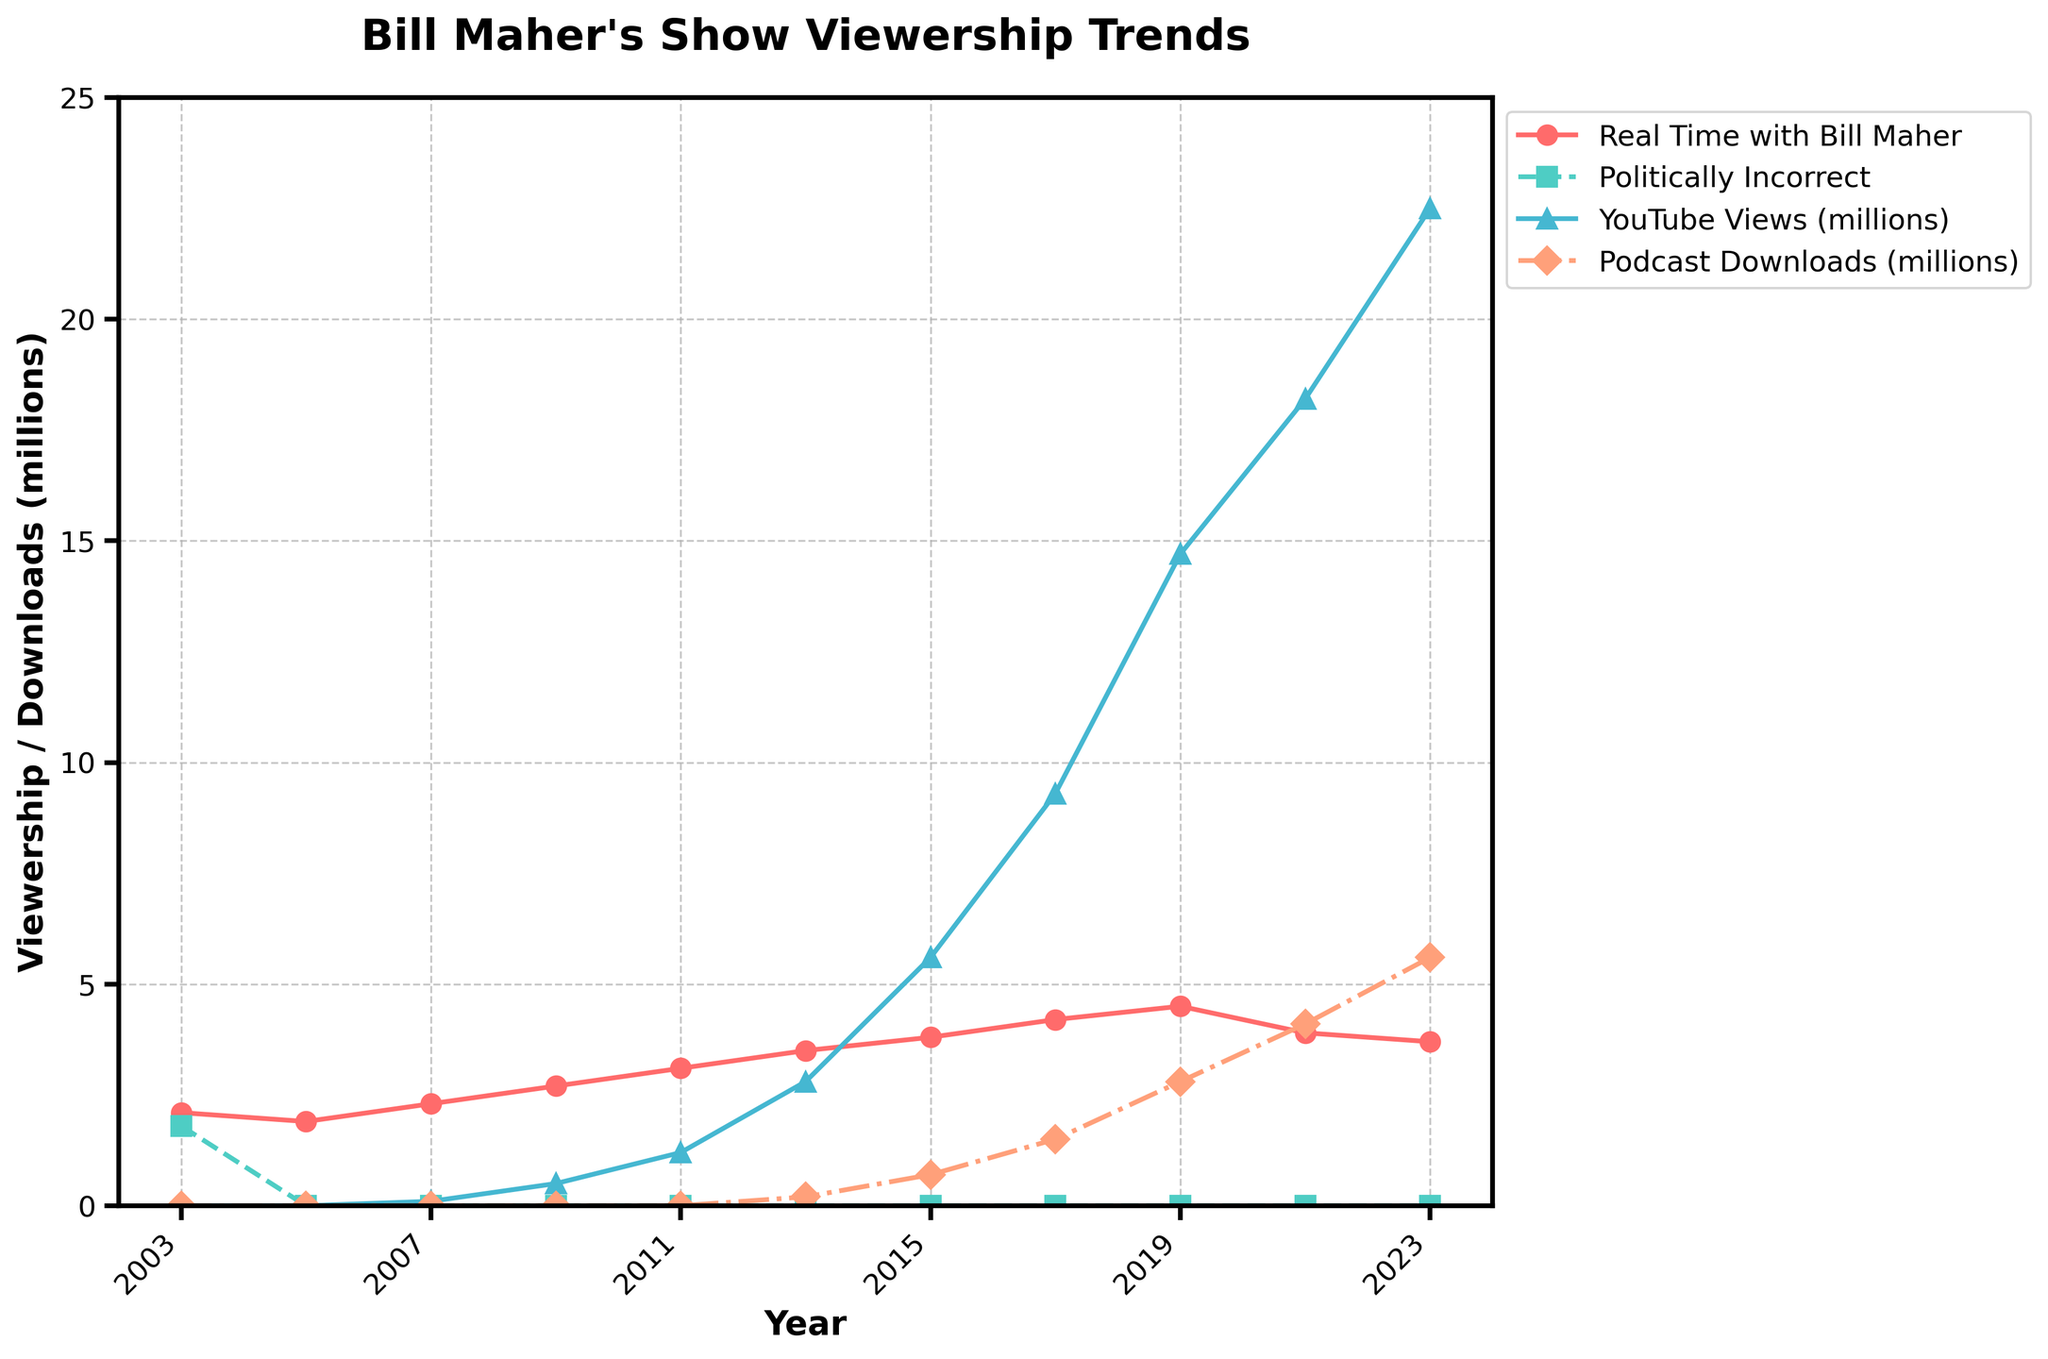What year did "Real Time with Bill Maher" have the highest viewership? To find the highest viewership for "Real Time with Bill Maher," look for the peak of the red line. The peak occurs in 2019 at 4.5 million viewers.
Answer: 2019 Which show has consistently higher viewership, "Real Time with Bill Maher" or "Politically Incorrect"? "Politically Incorrect" had a viewership only in 2003, whereas "Real Time with Bill Maher" has data from 2003 to 2023 and shows a general upward trend. Therefore, "Real Time with Bill Maher" has consistently higher viewership overall.
Answer: Real Time with Bill Maher What is the difference in YouTube views between 2017 and 2023? Look at the blue line representing YouTube views. In 2017, there were 9.3 million views; in 2023, there were 22.5 million views. The difference is 22.5 - 9.3 = 13.2 million views.
Answer: 13.2 million views How have podcast downloads changed from 2013 to 2023? View the orange line representing podcast downloads. In 2013, there were 0.2 million downloads, while in 2023, there were 5.6 million downloads. The change is 5.6 - 0.2 = 5.4 million downloads.
Answer: 5.4 million downloads Between which consecutive years did "Real Time with Bill Maher" see the most significant increase in viewership? Look at the red line and compare yearly increments. The most significant increase is between 2015 and 2017, where viewership increased from 3.8 million to 4.2 million, a difference of 0.4 million.
Answer: 2015-2017 Which year shows a decline in viewership for "Real Time with Bill Maher"? Follow the red line over the years and identify any drops. The viewership drops from 2019 (4.5 million) to 2021 (3.9 million).
Answer: 2021 In which year did YouTube views first surpass 10 million? Follow the blue line and identify the first year it is above 10 million. In 2017, YouTube views were 9.3 million, while in 2019, they were 14.7 million.
Answer: 2019 Compare the increase in YouTube views to the increase in podcast downloads between 2019 and 2021. Which one increased more, and by how much? From 2019 to 2021, YouTube views increased from 14.7 to 18.2 million (an increase of 3.5 million), whereas podcast downloads increased from 2.8 to 4.1 million (an increase of 1.3 million). So, YouTube views increased more by 2.2 million.
Answer: YouTube views by 2.2 million What was the combined total viewership (including TV, YouTube, and Podcast) in 2023? Sum up the viewership in 2023: "Real Time with Bill Maher" (3.7 million), YouTube views (22.5 million), and Podcast downloads (5.6 million). The total is 3.7 + 22.5 + 5.6 = 31.8 million.
Answer: 31.8 million 